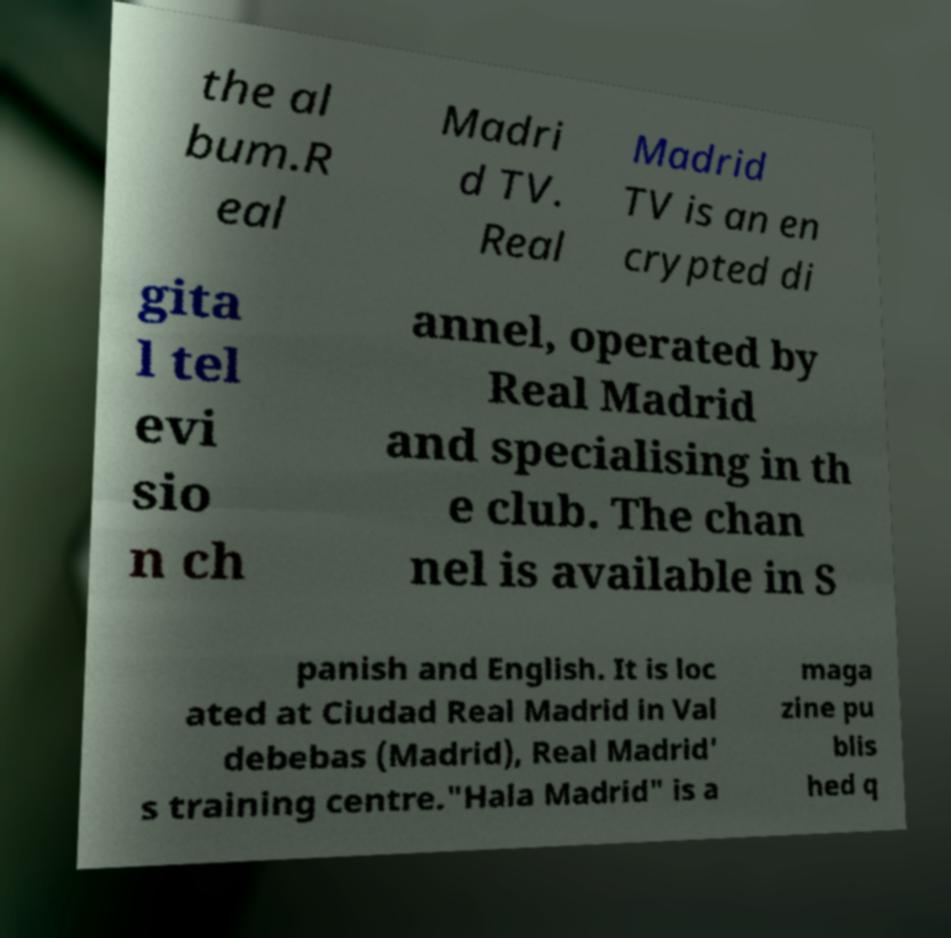Could you assist in decoding the text presented in this image and type it out clearly? the al bum.R eal Madri d TV. Real Madrid TV is an en crypted di gita l tel evi sio n ch annel, operated by Real Madrid and specialising in th e club. The chan nel is available in S panish and English. It is loc ated at Ciudad Real Madrid in Val debebas (Madrid), Real Madrid' s training centre."Hala Madrid" is a maga zine pu blis hed q 